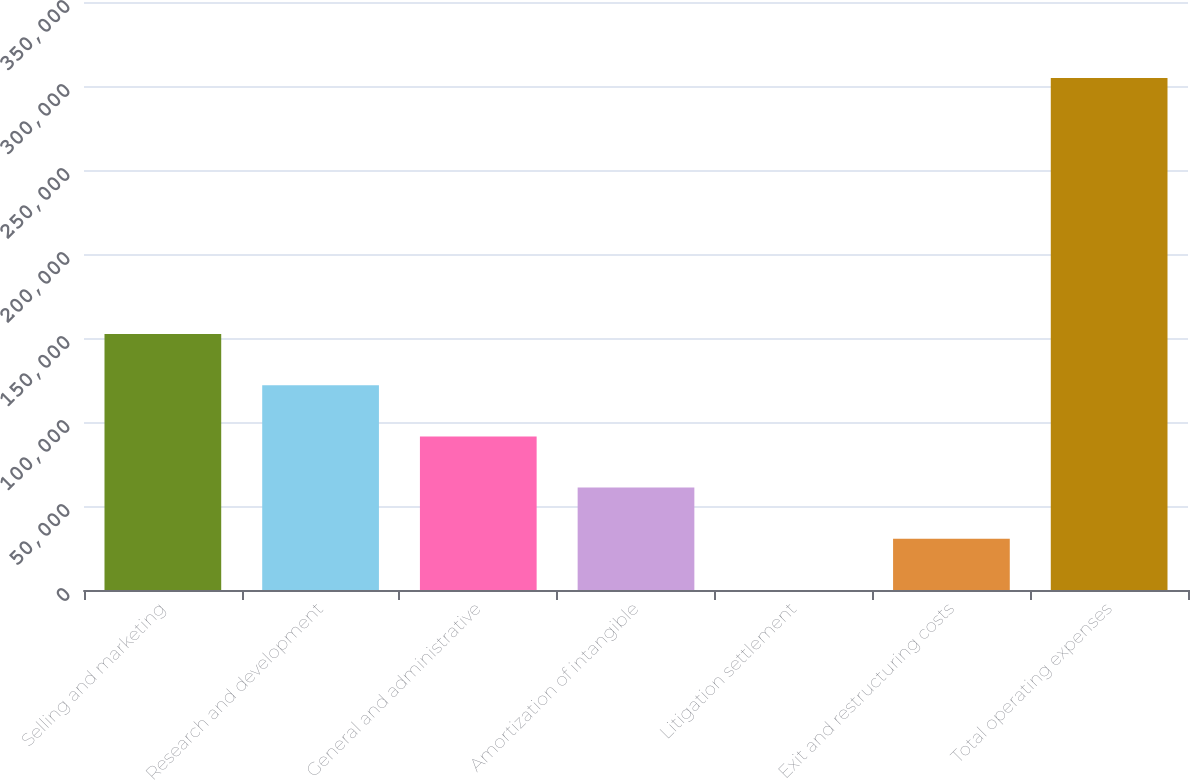<chart> <loc_0><loc_0><loc_500><loc_500><bar_chart><fcel>Selling and marketing<fcel>Research and development<fcel>General and administrative<fcel>Amortization of intangible<fcel>Litigation settlement<fcel>Exit and restructuring costs<fcel>Total operating expenses<nl><fcel>152369<fcel>121896<fcel>91423.2<fcel>60950.4<fcel>4.75<fcel>30477.6<fcel>304733<nl></chart> 